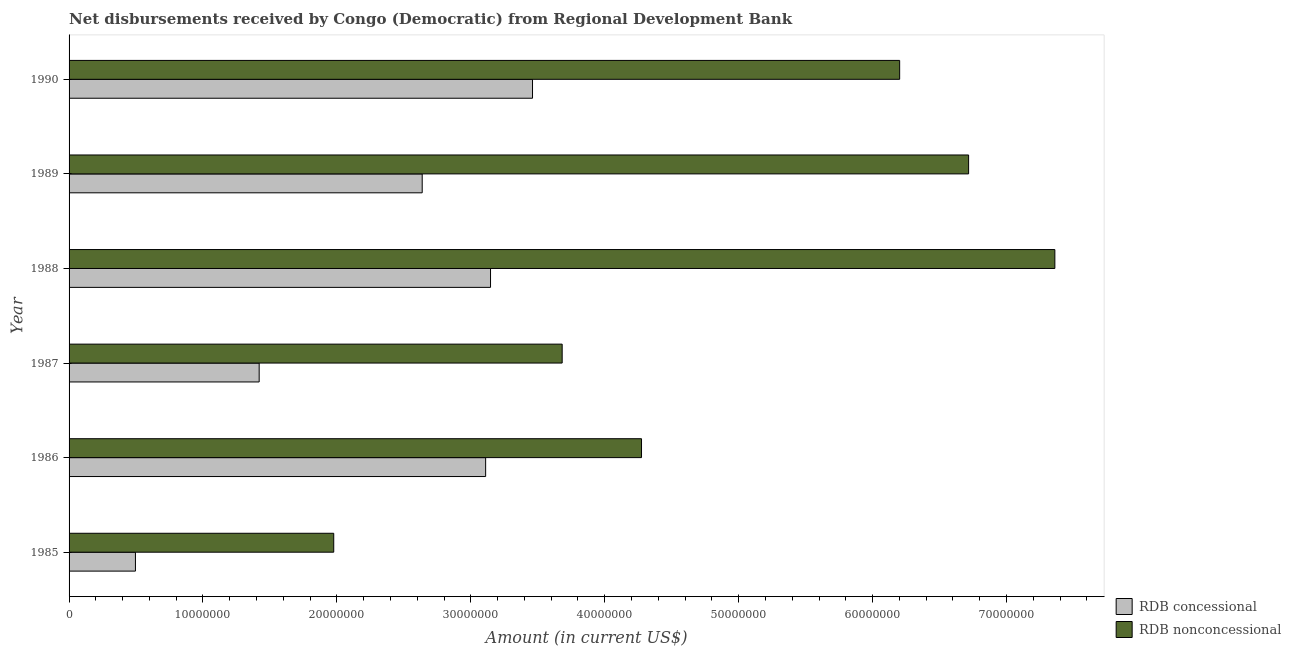How many different coloured bars are there?
Offer a terse response. 2. How many groups of bars are there?
Your response must be concise. 6. Are the number of bars per tick equal to the number of legend labels?
Provide a succinct answer. Yes. Are the number of bars on each tick of the Y-axis equal?
Offer a terse response. Yes. How many bars are there on the 4th tick from the bottom?
Keep it short and to the point. 2. What is the label of the 2nd group of bars from the top?
Offer a terse response. 1989. What is the net non concessional disbursements from rdb in 1986?
Offer a terse response. 4.27e+07. Across all years, what is the maximum net concessional disbursements from rdb?
Offer a terse response. 3.46e+07. Across all years, what is the minimum net concessional disbursements from rdb?
Provide a short and direct response. 4.96e+06. In which year was the net concessional disbursements from rdb maximum?
Give a very brief answer. 1990. What is the total net concessional disbursements from rdb in the graph?
Offer a very short reply. 1.43e+08. What is the difference between the net non concessional disbursements from rdb in 1985 and that in 1987?
Ensure brevity in your answer.  -1.71e+07. What is the difference between the net concessional disbursements from rdb in 1986 and the net non concessional disbursements from rdb in 1987?
Provide a short and direct response. -5.72e+06. What is the average net non concessional disbursements from rdb per year?
Make the answer very short. 5.04e+07. In the year 1989, what is the difference between the net non concessional disbursements from rdb and net concessional disbursements from rdb?
Your response must be concise. 4.08e+07. In how many years, is the net non concessional disbursements from rdb greater than 70000000 US$?
Offer a very short reply. 1. What is the ratio of the net concessional disbursements from rdb in 1985 to that in 1990?
Offer a very short reply. 0.14. Is the difference between the net non concessional disbursements from rdb in 1986 and 1989 greater than the difference between the net concessional disbursements from rdb in 1986 and 1989?
Provide a short and direct response. No. What is the difference between the highest and the second highest net non concessional disbursements from rdb?
Your response must be concise. 6.44e+06. What is the difference between the highest and the lowest net concessional disbursements from rdb?
Provide a succinct answer. 2.97e+07. What does the 2nd bar from the top in 1987 represents?
Offer a very short reply. RDB concessional. What does the 1st bar from the bottom in 1987 represents?
Your answer should be very brief. RDB concessional. How many bars are there?
Provide a short and direct response. 12. What is the difference between two consecutive major ticks on the X-axis?
Make the answer very short. 1.00e+07. Are the values on the major ticks of X-axis written in scientific E-notation?
Ensure brevity in your answer.  No. Does the graph contain any zero values?
Your response must be concise. No. Where does the legend appear in the graph?
Make the answer very short. Bottom right. How are the legend labels stacked?
Make the answer very short. Vertical. What is the title of the graph?
Give a very brief answer. Net disbursements received by Congo (Democratic) from Regional Development Bank. What is the label or title of the X-axis?
Keep it short and to the point. Amount (in current US$). What is the Amount (in current US$) of RDB concessional in 1985?
Your answer should be compact. 4.96e+06. What is the Amount (in current US$) of RDB nonconcessional in 1985?
Ensure brevity in your answer.  1.98e+07. What is the Amount (in current US$) of RDB concessional in 1986?
Keep it short and to the point. 3.11e+07. What is the Amount (in current US$) of RDB nonconcessional in 1986?
Your answer should be very brief. 4.27e+07. What is the Amount (in current US$) in RDB concessional in 1987?
Your answer should be very brief. 1.42e+07. What is the Amount (in current US$) of RDB nonconcessional in 1987?
Ensure brevity in your answer.  3.68e+07. What is the Amount (in current US$) of RDB concessional in 1988?
Give a very brief answer. 3.15e+07. What is the Amount (in current US$) of RDB nonconcessional in 1988?
Offer a very short reply. 7.36e+07. What is the Amount (in current US$) in RDB concessional in 1989?
Offer a terse response. 2.64e+07. What is the Amount (in current US$) in RDB nonconcessional in 1989?
Your answer should be compact. 6.72e+07. What is the Amount (in current US$) in RDB concessional in 1990?
Provide a short and direct response. 3.46e+07. What is the Amount (in current US$) of RDB nonconcessional in 1990?
Give a very brief answer. 6.20e+07. Across all years, what is the maximum Amount (in current US$) in RDB concessional?
Ensure brevity in your answer.  3.46e+07. Across all years, what is the maximum Amount (in current US$) in RDB nonconcessional?
Your answer should be compact. 7.36e+07. Across all years, what is the minimum Amount (in current US$) in RDB concessional?
Make the answer very short. 4.96e+06. Across all years, what is the minimum Amount (in current US$) of RDB nonconcessional?
Ensure brevity in your answer.  1.98e+07. What is the total Amount (in current US$) in RDB concessional in the graph?
Ensure brevity in your answer.  1.43e+08. What is the total Amount (in current US$) in RDB nonconcessional in the graph?
Ensure brevity in your answer.  3.02e+08. What is the difference between the Amount (in current US$) in RDB concessional in 1985 and that in 1986?
Your response must be concise. -2.62e+07. What is the difference between the Amount (in current US$) in RDB nonconcessional in 1985 and that in 1986?
Keep it short and to the point. -2.30e+07. What is the difference between the Amount (in current US$) in RDB concessional in 1985 and that in 1987?
Your answer should be compact. -9.24e+06. What is the difference between the Amount (in current US$) in RDB nonconcessional in 1985 and that in 1987?
Offer a very short reply. -1.71e+07. What is the difference between the Amount (in current US$) of RDB concessional in 1985 and that in 1988?
Offer a terse response. -2.65e+07. What is the difference between the Amount (in current US$) in RDB nonconcessional in 1985 and that in 1988?
Ensure brevity in your answer.  -5.38e+07. What is the difference between the Amount (in current US$) of RDB concessional in 1985 and that in 1989?
Offer a very short reply. -2.14e+07. What is the difference between the Amount (in current US$) of RDB nonconcessional in 1985 and that in 1989?
Offer a very short reply. -4.74e+07. What is the difference between the Amount (in current US$) of RDB concessional in 1985 and that in 1990?
Provide a short and direct response. -2.97e+07. What is the difference between the Amount (in current US$) in RDB nonconcessional in 1985 and that in 1990?
Provide a succinct answer. -4.23e+07. What is the difference between the Amount (in current US$) in RDB concessional in 1986 and that in 1987?
Provide a succinct answer. 1.69e+07. What is the difference between the Amount (in current US$) of RDB nonconcessional in 1986 and that in 1987?
Keep it short and to the point. 5.92e+06. What is the difference between the Amount (in current US$) of RDB concessional in 1986 and that in 1988?
Offer a very short reply. -3.65e+05. What is the difference between the Amount (in current US$) of RDB nonconcessional in 1986 and that in 1988?
Offer a very short reply. -3.09e+07. What is the difference between the Amount (in current US$) of RDB concessional in 1986 and that in 1989?
Your answer should be compact. 4.74e+06. What is the difference between the Amount (in current US$) of RDB nonconcessional in 1986 and that in 1989?
Provide a succinct answer. -2.44e+07. What is the difference between the Amount (in current US$) in RDB concessional in 1986 and that in 1990?
Your answer should be very brief. -3.50e+06. What is the difference between the Amount (in current US$) of RDB nonconcessional in 1986 and that in 1990?
Offer a terse response. -1.93e+07. What is the difference between the Amount (in current US$) in RDB concessional in 1987 and that in 1988?
Provide a short and direct response. -1.73e+07. What is the difference between the Amount (in current US$) of RDB nonconcessional in 1987 and that in 1988?
Provide a short and direct response. -3.68e+07. What is the difference between the Amount (in current US$) in RDB concessional in 1987 and that in 1989?
Your response must be concise. -1.22e+07. What is the difference between the Amount (in current US$) in RDB nonconcessional in 1987 and that in 1989?
Make the answer very short. -3.03e+07. What is the difference between the Amount (in current US$) in RDB concessional in 1987 and that in 1990?
Offer a very short reply. -2.04e+07. What is the difference between the Amount (in current US$) of RDB nonconcessional in 1987 and that in 1990?
Provide a succinct answer. -2.52e+07. What is the difference between the Amount (in current US$) of RDB concessional in 1988 and that in 1989?
Keep it short and to the point. 5.10e+06. What is the difference between the Amount (in current US$) of RDB nonconcessional in 1988 and that in 1989?
Your answer should be very brief. 6.44e+06. What is the difference between the Amount (in current US$) in RDB concessional in 1988 and that in 1990?
Your answer should be compact. -3.14e+06. What is the difference between the Amount (in current US$) of RDB nonconcessional in 1988 and that in 1990?
Ensure brevity in your answer.  1.16e+07. What is the difference between the Amount (in current US$) in RDB concessional in 1989 and that in 1990?
Provide a succinct answer. -8.24e+06. What is the difference between the Amount (in current US$) in RDB nonconcessional in 1989 and that in 1990?
Give a very brief answer. 5.15e+06. What is the difference between the Amount (in current US$) of RDB concessional in 1985 and the Amount (in current US$) of RDB nonconcessional in 1986?
Your response must be concise. -3.78e+07. What is the difference between the Amount (in current US$) in RDB concessional in 1985 and the Amount (in current US$) in RDB nonconcessional in 1987?
Provide a succinct answer. -3.19e+07. What is the difference between the Amount (in current US$) of RDB concessional in 1985 and the Amount (in current US$) of RDB nonconcessional in 1988?
Your answer should be compact. -6.87e+07. What is the difference between the Amount (in current US$) of RDB concessional in 1985 and the Amount (in current US$) of RDB nonconcessional in 1989?
Give a very brief answer. -6.22e+07. What is the difference between the Amount (in current US$) in RDB concessional in 1985 and the Amount (in current US$) in RDB nonconcessional in 1990?
Give a very brief answer. -5.71e+07. What is the difference between the Amount (in current US$) in RDB concessional in 1986 and the Amount (in current US$) in RDB nonconcessional in 1987?
Keep it short and to the point. -5.72e+06. What is the difference between the Amount (in current US$) of RDB concessional in 1986 and the Amount (in current US$) of RDB nonconcessional in 1988?
Give a very brief answer. -4.25e+07. What is the difference between the Amount (in current US$) in RDB concessional in 1986 and the Amount (in current US$) in RDB nonconcessional in 1989?
Keep it short and to the point. -3.61e+07. What is the difference between the Amount (in current US$) in RDB concessional in 1986 and the Amount (in current US$) in RDB nonconcessional in 1990?
Your answer should be compact. -3.09e+07. What is the difference between the Amount (in current US$) of RDB concessional in 1987 and the Amount (in current US$) of RDB nonconcessional in 1988?
Your answer should be compact. -5.94e+07. What is the difference between the Amount (in current US$) in RDB concessional in 1987 and the Amount (in current US$) in RDB nonconcessional in 1989?
Provide a succinct answer. -5.30e+07. What is the difference between the Amount (in current US$) of RDB concessional in 1987 and the Amount (in current US$) of RDB nonconcessional in 1990?
Provide a short and direct response. -4.78e+07. What is the difference between the Amount (in current US$) in RDB concessional in 1988 and the Amount (in current US$) in RDB nonconcessional in 1989?
Give a very brief answer. -3.57e+07. What is the difference between the Amount (in current US$) in RDB concessional in 1988 and the Amount (in current US$) in RDB nonconcessional in 1990?
Your answer should be compact. -3.06e+07. What is the difference between the Amount (in current US$) of RDB concessional in 1989 and the Amount (in current US$) of RDB nonconcessional in 1990?
Your response must be concise. -3.57e+07. What is the average Amount (in current US$) in RDB concessional per year?
Make the answer very short. 2.38e+07. What is the average Amount (in current US$) in RDB nonconcessional per year?
Provide a succinct answer. 5.04e+07. In the year 1985, what is the difference between the Amount (in current US$) in RDB concessional and Amount (in current US$) in RDB nonconcessional?
Your answer should be compact. -1.48e+07. In the year 1986, what is the difference between the Amount (in current US$) of RDB concessional and Amount (in current US$) of RDB nonconcessional?
Offer a very short reply. -1.16e+07. In the year 1987, what is the difference between the Amount (in current US$) in RDB concessional and Amount (in current US$) in RDB nonconcessional?
Offer a terse response. -2.26e+07. In the year 1988, what is the difference between the Amount (in current US$) of RDB concessional and Amount (in current US$) of RDB nonconcessional?
Offer a terse response. -4.21e+07. In the year 1989, what is the difference between the Amount (in current US$) of RDB concessional and Amount (in current US$) of RDB nonconcessional?
Your answer should be compact. -4.08e+07. In the year 1990, what is the difference between the Amount (in current US$) in RDB concessional and Amount (in current US$) in RDB nonconcessional?
Your answer should be compact. -2.74e+07. What is the ratio of the Amount (in current US$) in RDB concessional in 1985 to that in 1986?
Make the answer very short. 0.16. What is the ratio of the Amount (in current US$) of RDB nonconcessional in 1985 to that in 1986?
Your response must be concise. 0.46. What is the ratio of the Amount (in current US$) in RDB concessional in 1985 to that in 1987?
Provide a short and direct response. 0.35. What is the ratio of the Amount (in current US$) of RDB nonconcessional in 1985 to that in 1987?
Your answer should be very brief. 0.54. What is the ratio of the Amount (in current US$) in RDB concessional in 1985 to that in 1988?
Make the answer very short. 0.16. What is the ratio of the Amount (in current US$) in RDB nonconcessional in 1985 to that in 1988?
Your answer should be very brief. 0.27. What is the ratio of the Amount (in current US$) in RDB concessional in 1985 to that in 1989?
Offer a very short reply. 0.19. What is the ratio of the Amount (in current US$) of RDB nonconcessional in 1985 to that in 1989?
Give a very brief answer. 0.29. What is the ratio of the Amount (in current US$) of RDB concessional in 1985 to that in 1990?
Your answer should be compact. 0.14. What is the ratio of the Amount (in current US$) in RDB nonconcessional in 1985 to that in 1990?
Offer a very short reply. 0.32. What is the ratio of the Amount (in current US$) of RDB concessional in 1986 to that in 1987?
Your answer should be very brief. 2.19. What is the ratio of the Amount (in current US$) of RDB nonconcessional in 1986 to that in 1987?
Give a very brief answer. 1.16. What is the ratio of the Amount (in current US$) in RDB concessional in 1986 to that in 1988?
Your answer should be very brief. 0.99. What is the ratio of the Amount (in current US$) of RDB nonconcessional in 1986 to that in 1988?
Your answer should be very brief. 0.58. What is the ratio of the Amount (in current US$) in RDB concessional in 1986 to that in 1989?
Provide a succinct answer. 1.18. What is the ratio of the Amount (in current US$) of RDB nonconcessional in 1986 to that in 1989?
Give a very brief answer. 0.64. What is the ratio of the Amount (in current US$) of RDB concessional in 1986 to that in 1990?
Your answer should be very brief. 0.9. What is the ratio of the Amount (in current US$) in RDB nonconcessional in 1986 to that in 1990?
Your answer should be very brief. 0.69. What is the ratio of the Amount (in current US$) of RDB concessional in 1987 to that in 1988?
Give a very brief answer. 0.45. What is the ratio of the Amount (in current US$) of RDB nonconcessional in 1987 to that in 1988?
Offer a terse response. 0.5. What is the ratio of the Amount (in current US$) in RDB concessional in 1987 to that in 1989?
Offer a very short reply. 0.54. What is the ratio of the Amount (in current US$) of RDB nonconcessional in 1987 to that in 1989?
Your answer should be compact. 0.55. What is the ratio of the Amount (in current US$) of RDB concessional in 1987 to that in 1990?
Make the answer very short. 0.41. What is the ratio of the Amount (in current US$) in RDB nonconcessional in 1987 to that in 1990?
Your answer should be compact. 0.59. What is the ratio of the Amount (in current US$) in RDB concessional in 1988 to that in 1989?
Make the answer very short. 1.19. What is the ratio of the Amount (in current US$) in RDB nonconcessional in 1988 to that in 1989?
Provide a succinct answer. 1.1. What is the ratio of the Amount (in current US$) in RDB concessional in 1988 to that in 1990?
Keep it short and to the point. 0.91. What is the ratio of the Amount (in current US$) of RDB nonconcessional in 1988 to that in 1990?
Keep it short and to the point. 1.19. What is the ratio of the Amount (in current US$) of RDB concessional in 1989 to that in 1990?
Your response must be concise. 0.76. What is the ratio of the Amount (in current US$) of RDB nonconcessional in 1989 to that in 1990?
Keep it short and to the point. 1.08. What is the difference between the highest and the second highest Amount (in current US$) of RDB concessional?
Your answer should be compact. 3.14e+06. What is the difference between the highest and the second highest Amount (in current US$) of RDB nonconcessional?
Your answer should be compact. 6.44e+06. What is the difference between the highest and the lowest Amount (in current US$) of RDB concessional?
Your answer should be very brief. 2.97e+07. What is the difference between the highest and the lowest Amount (in current US$) of RDB nonconcessional?
Make the answer very short. 5.38e+07. 